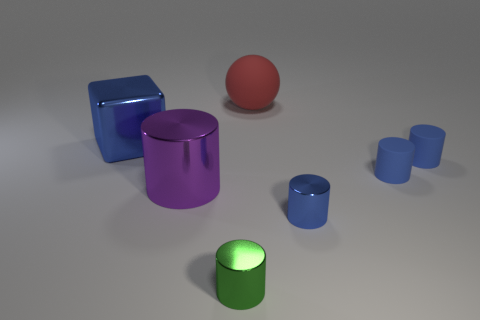Are there more spheres that are behind the large red matte object than blue matte cylinders?
Ensure brevity in your answer.  No. How many other things are the same size as the green metallic cylinder?
Make the answer very short. 3. Do the big metal cylinder and the matte sphere have the same color?
Offer a very short reply. No. The big thing that is to the right of the small metal object on the left side of the small metallic cylinder right of the red ball is what color?
Provide a succinct answer. Red. There is a small shiny object that is left of the shiny object to the right of the large red sphere; what number of tiny metallic objects are on the right side of it?
Your answer should be compact. 1. Is there anything else of the same color as the big rubber ball?
Ensure brevity in your answer.  No. Do the blue metallic thing to the left of the purple thing and the green metallic object have the same size?
Ensure brevity in your answer.  No. There is a metallic thing that is right of the big red matte object; how many tiny shiny cylinders are behind it?
Offer a terse response. 0. Are there any big cylinders behind the metal cylinder that is behind the blue shiny thing to the right of the big red sphere?
Provide a succinct answer. No. There is a large object that is the same shape as the tiny green object; what is it made of?
Offer a very short reply. Metal. 